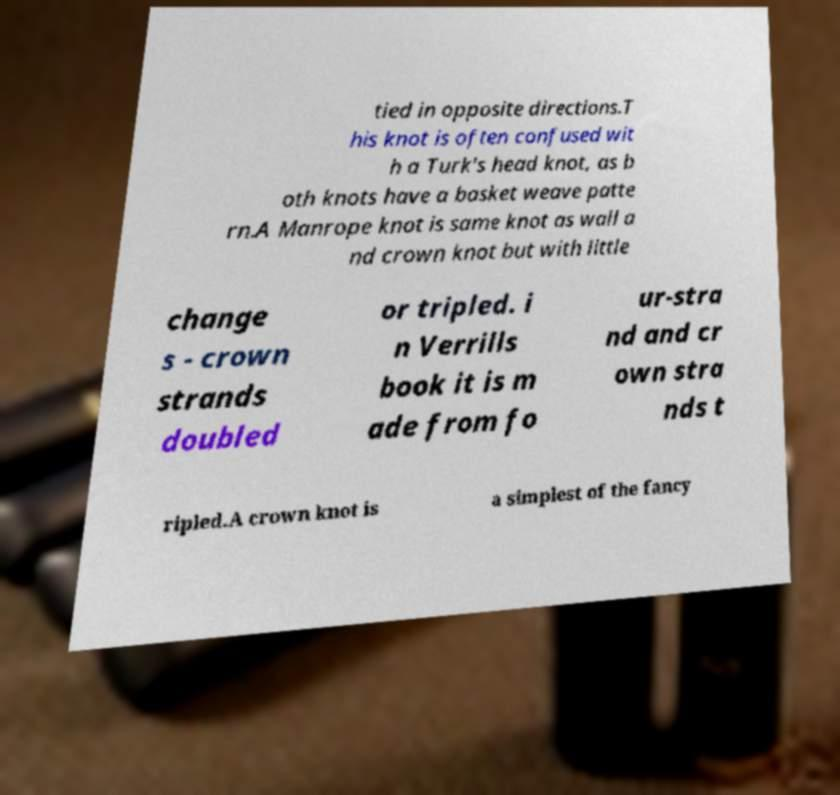Please identify and transcribe the text found in this image. tied in opposite directions.T his knot is often confused wit h a Turk's head knot, as b oth knots have a basket weave patte rn.A Manrope knot is same knot as wall a nd crown knot but with little change s - crown strands doubled or tripled. i n Verrills book it is m ade from fo ur-stra nd and cr own stra nds t ripled.A crown knot is a simplest of the fancy 